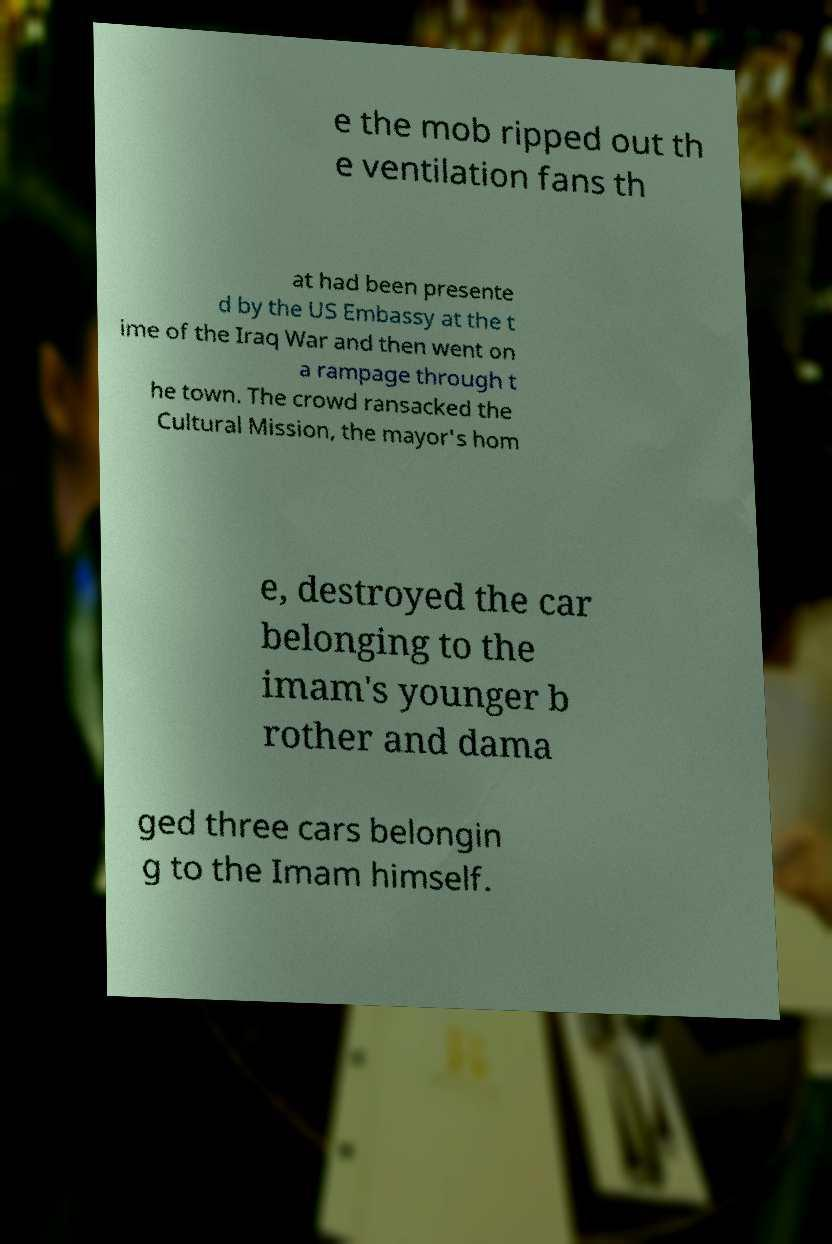What messages or text are displayed in this image? I need them in a readable, typed format. e the mob ripped out th e ventilation fans th at had been presente d by the US Embassy at the t ime of the Iraq War and then went on a rampage through t he town. The crowd ransacked the Cultural Mission, the mayor's hom e, destroyed the car belonging to the imam's younger b rother and dama ged three cars belongin g to the Imam himself. 